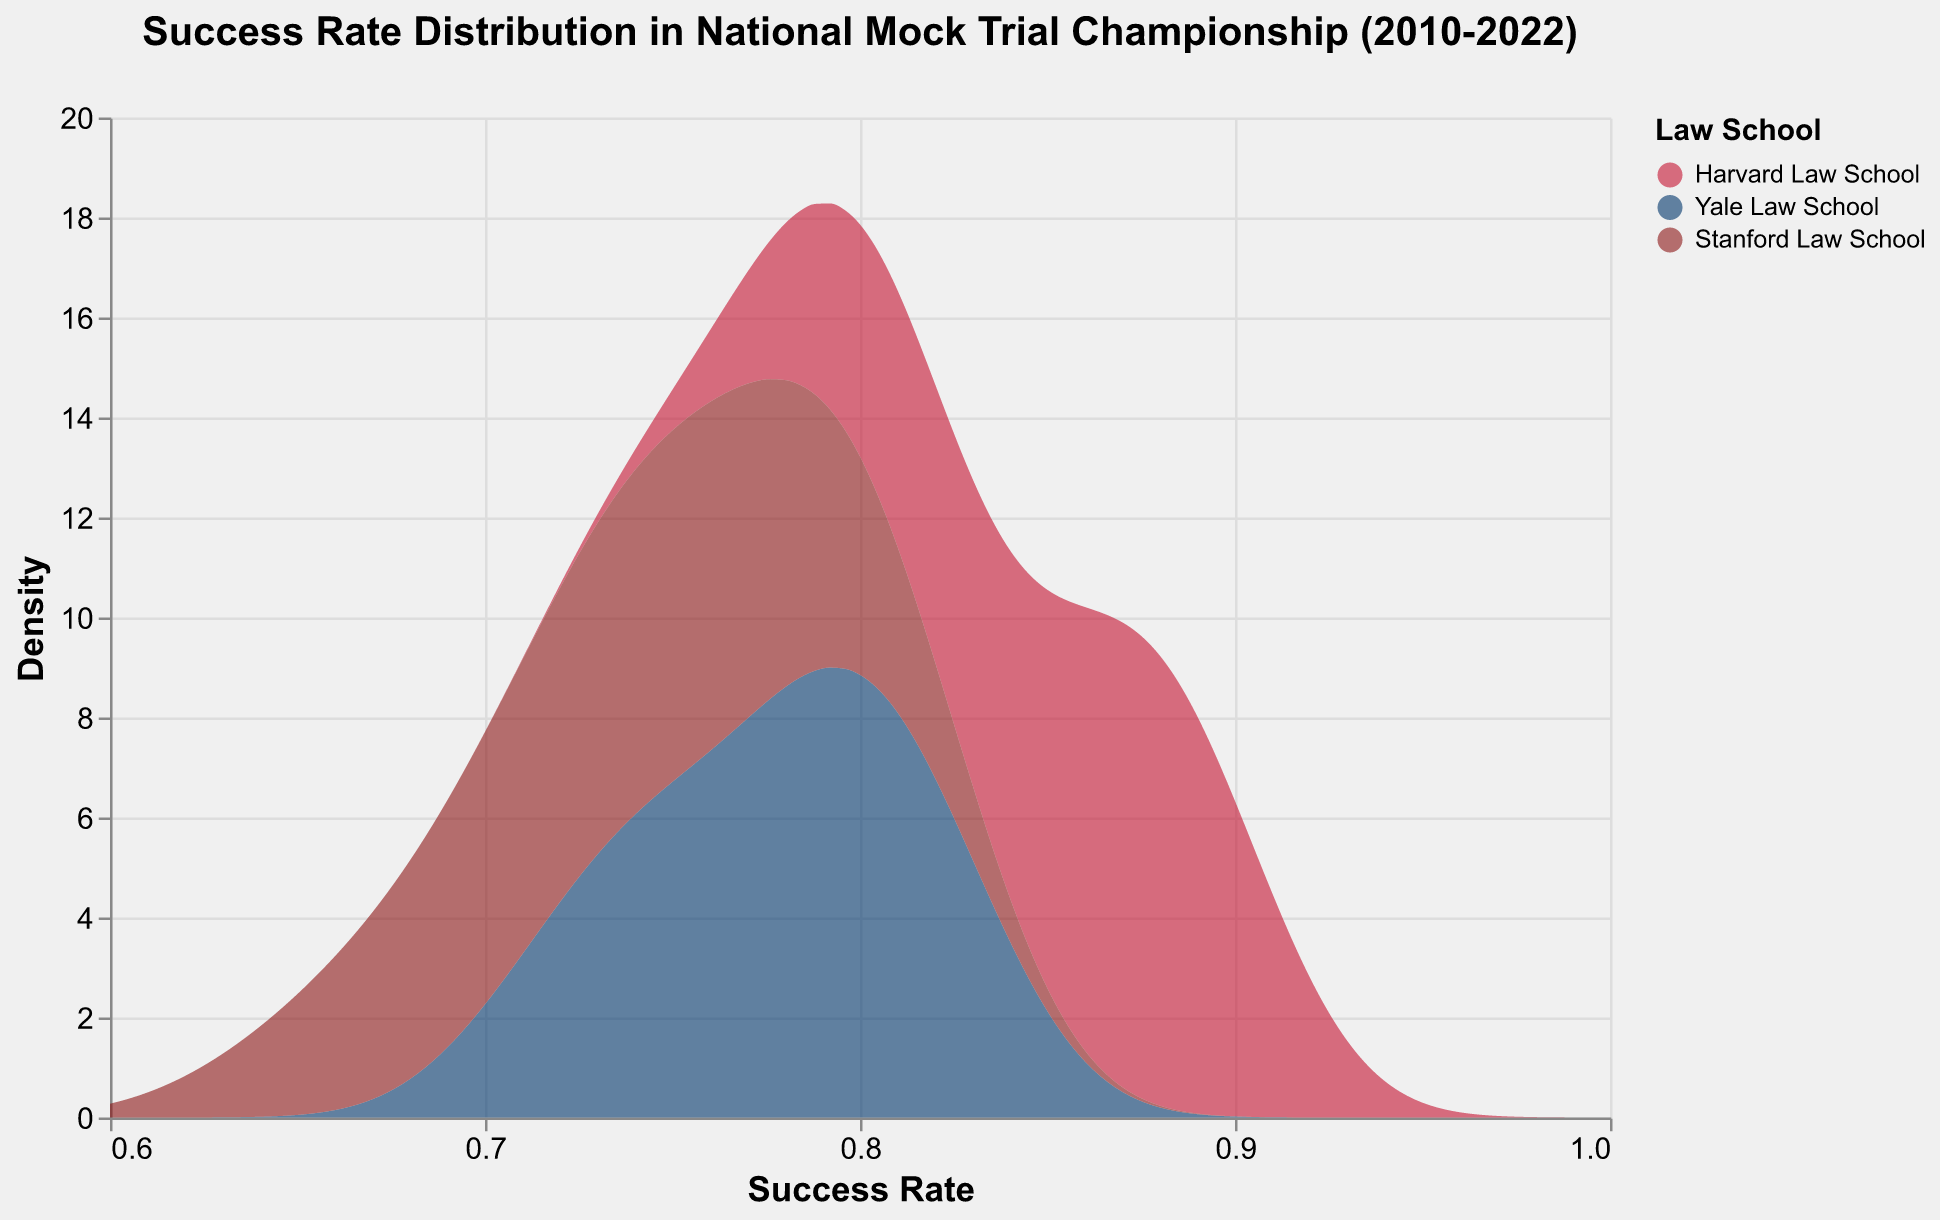What is the title of the plot? The title is usually located at the top of the plot. It summarizes what the data represents. Here, the title is "Success Rate Distribution in National Mock Trial Championship (2010-2022)".
Answer: Success Rate Distribution in National Mock Trial Championship (2010-2022) Which team has the highest success rate density? To determine the team with the highest success rate density, look for the peak (highest value) in the density curves. The highest peak corresponds to the highest density.
Answer: Harvard Law School What are the success rate ranges shown on the x-axis? The x-axis represents the success rates, and the plot’s schema specifies the overall extent. Here, the success rate ranges from 0.6 to 1.0 as indicated.
Answer: 0.6 to 1.0 How do the success rates of Yale Law School and Stanford Law School compare? To compare, look at the density curves for Yale and Stanford. Assess their shapes and peaks across the success rate range. Yale tends to have higher success rates compared to Stanford.
Answer: Yale Law School generally has higher success rates What is a notable trend for Harvard Law School's success rate over time? By looking at Harvard's density curve, we can see the trend. The density peaks are consistently at higher success rates, indicating strong performance across the years.
Answer: Harvard Law School consistently shows high success rates Around what success rate does Stanford Law School peak? To identify Stanford's peak success rate, find the highest point on Stanford's density curve. This peak is approximately around 0.75 to 0.80.
Answer: Around 0.75 to 0.80 Which team shows the most variability in success rates? To assess variability, observe the density curves' spread. Stanford's curve is more spread out, indicating higher variability.
Answer: Stanford Law School What is the general shape of the density plot for Yale Law School? The general shape can be described by the curve's peaks and tails. Yale Law School's density plot shows a high peak around 0.8 and tapers off towards both ends.
Answer: High peak around 0.8 Does any team have a success rate consistently below 0.70? Check the density curves to see if any has significant density below 0.70. None of the teams have notable density below this threshold.
Answer: No How does the peak density value of Harvard compare to Yale's? To compare peak densities, find the highest points on both curves. Harvard's peak density value is higher than Yale's peak density value.
Answer: Harvard's peak density is higher 